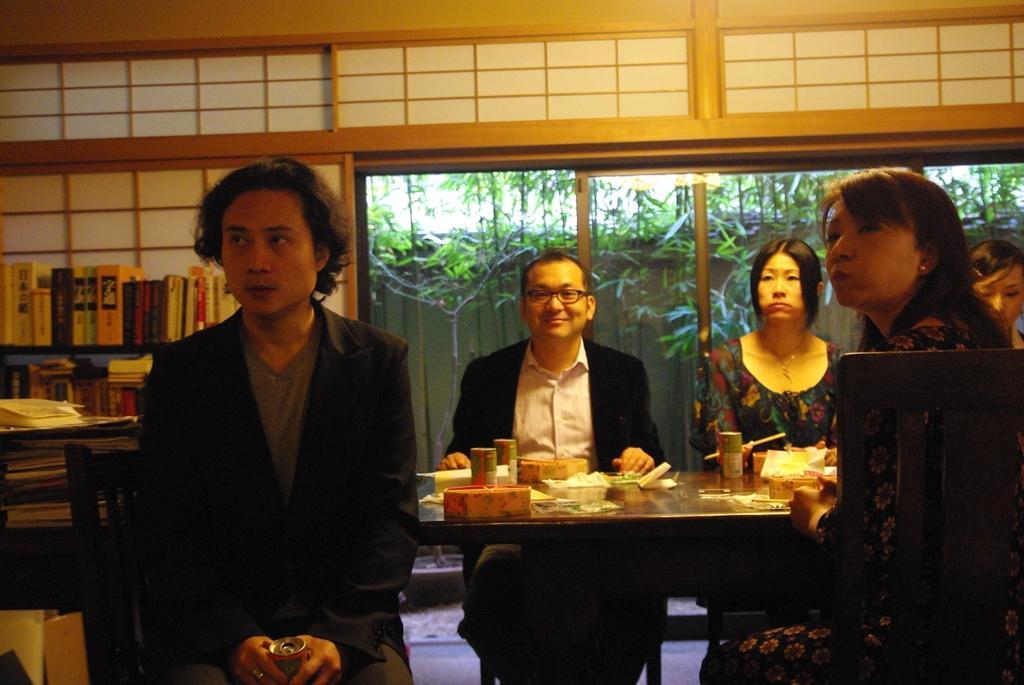Please provide a concise description of this image. As we can see in the image there is a window, trees, few people sitting on chairs, books and a table. 